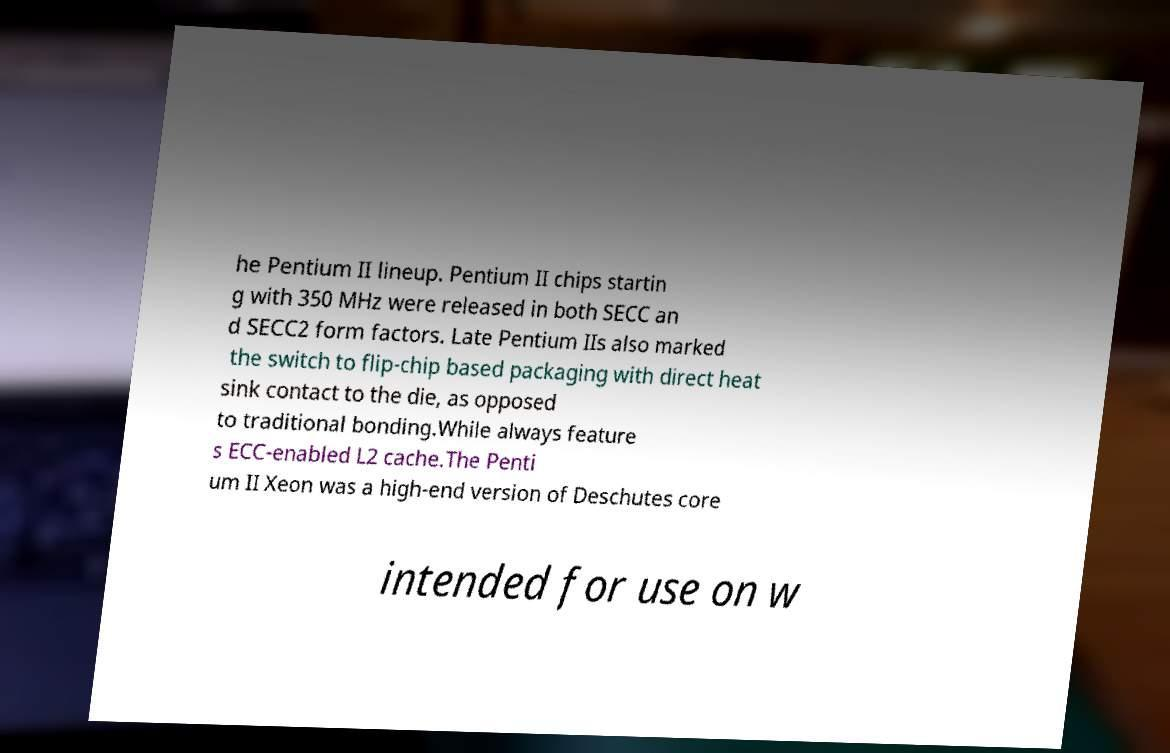What messages or text are displayed in this image? I need them in a readable, typed format. he Pentium II lineup. Pentium II chips startin g with 350 MHz were released in both SECC an d SECC2 form factors. Late Pentium IIs also marked the switch to flip-chip based packaging with direct heat sink contact to the die, as opposed to traditional bonding.While always feature s ECC-enabled L2 cache.The Penti um II Xeon was a high-end version of Deschutes core intended for use on w 